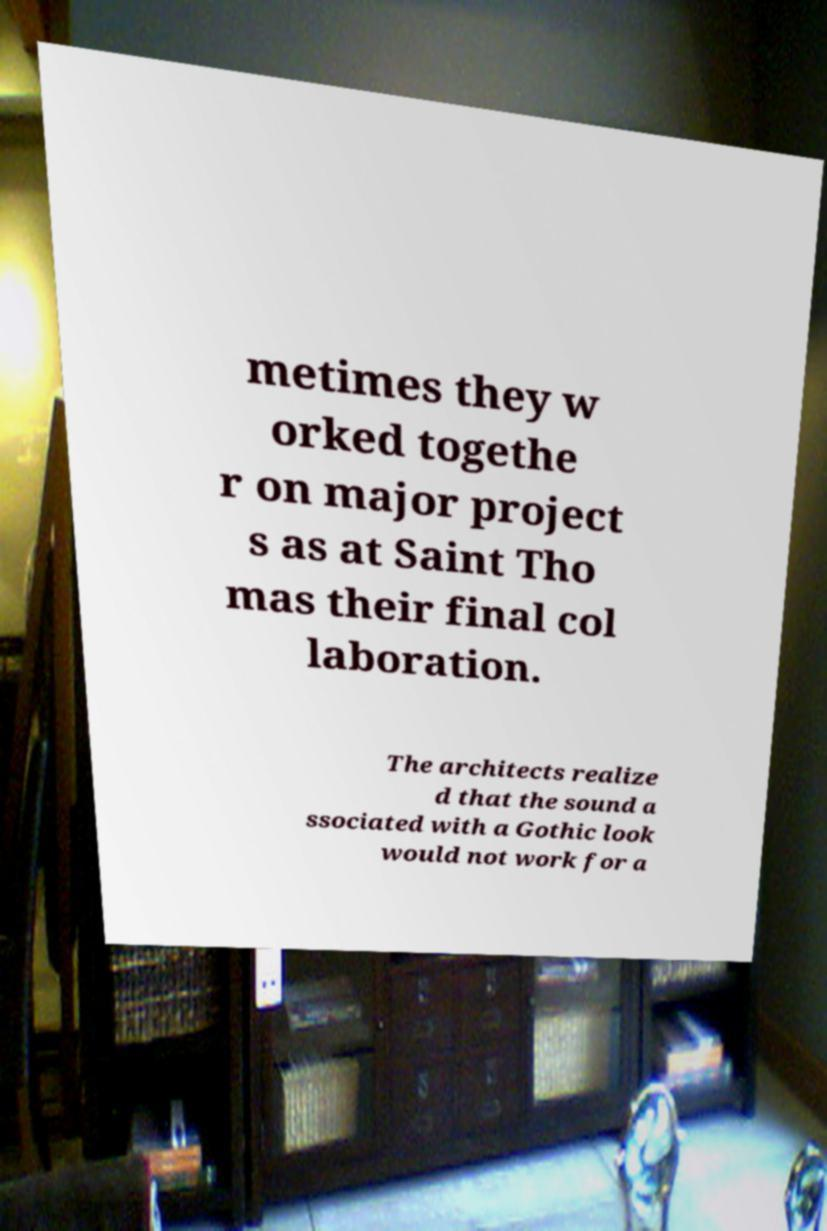Could you extract and type out the text from this image? metimes they w orked togethe r on major project s as at Saint Tho mas their final col laboration. The architects realize d that the sound a ssociated with a Gothic look would not work for a 